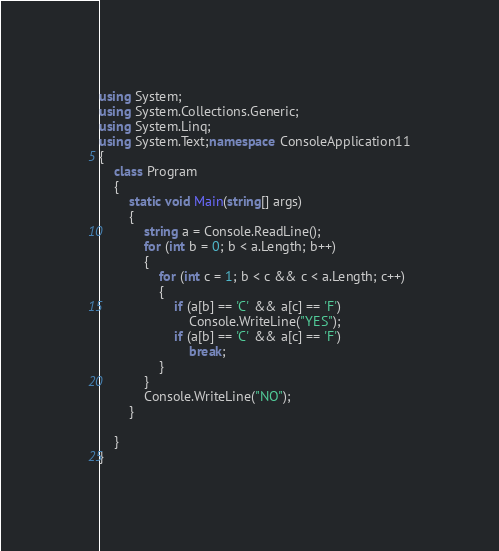Convert code to text. <code><loc_0><loc_0><loc_500><loc_500><_C#_>using System;
using System.Collections.Generic;
using System.Linq;
using System.Text;namespace ConsoleApplication11
{
    class Program
    {
        static void Main(string[] args)
        {
            string a = Console.ReadLine();
            for (int b = 0; b < a.Length; b++)
            {
                for (int c = 1; b < c && c < a.Length; c++)
                {
                    if (a[b] == 'C' && a[c] == 'F')
                        Console.WriteLine("YES");
                    if (a[b] == 'C' && a[c] == 'F')
                        break;
                }
            }
            Console.WriteLine("NO");
        }

    }
}
</code> 